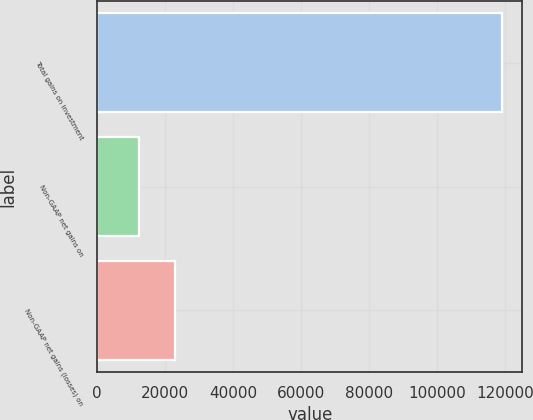<chart> <loc_0><loc_0><loc_500><loc_500><bar_chart><fcel>Total gains on investment<fcel>Non-GAAP net gains on<fcel>Non-GAAP net gains (losses) on<nl><fcel>119095<fcel>12225<fcel>22912<nl></chart> 